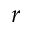Convert formula to latex. <formula><loc_0><loc_0><loc_500><loc_500>r</formula> 